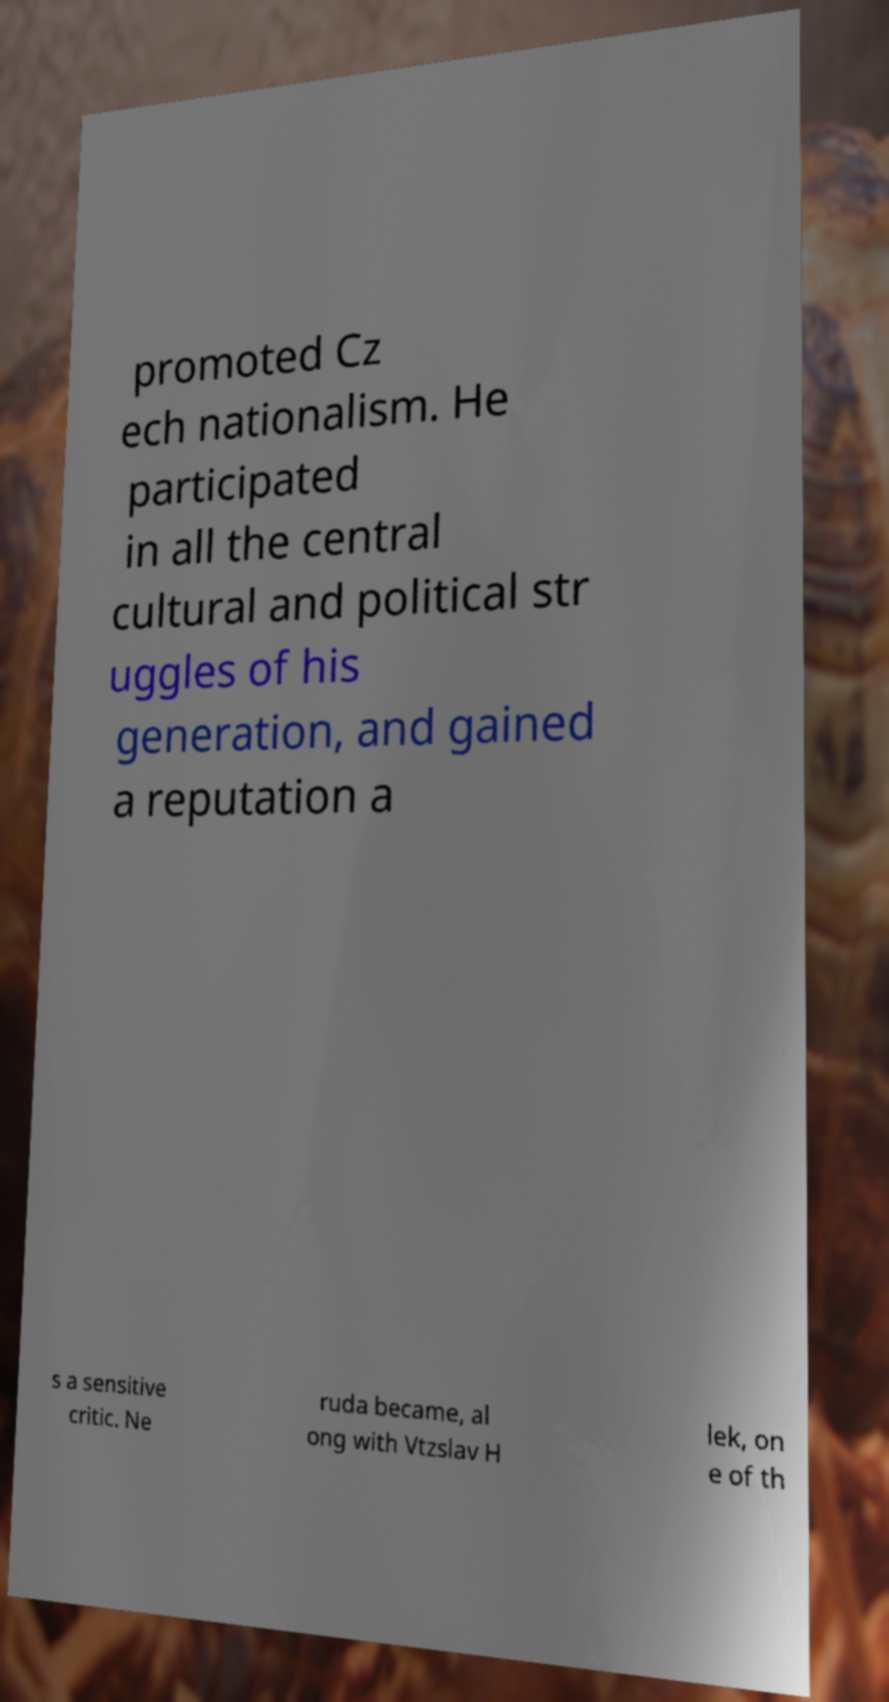Could you assist in decoding the text presented in this image and type it out clearly? promoted Cz ech nationalism. He participated in all the central cultural and political str uggles of his generation, and gained a reputation a s a sensitive critic. Ne ruda became, al ong with Vtzslav H lek, on e of th 